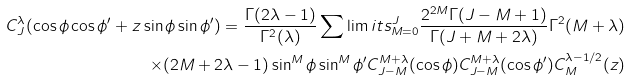<formula> <loc_0><loc_0><loc_500><loc_500>C _ { J } ^ { \lambda } ( \cos \phi \cos \phi ^ { \prime } + z \sin \phi \sin \phi ^ { \prime } ) = \frac { \Gamma ( 2 \lambda - 1 ) } { \Gamma ^ { 2 } ( \lambda ) } \sum \lim i t s _ { M = 0 } ^ { J } \frac { 2 ^ { 2 M } \Gamma ( J - M + 1 ) } { \Gamma ( J + M + 2 \lambda ) } \Gamma ^ { 2 } ( M + \lambda ) \\ \times ( 2 M + 2 \lambda - 1 ) \sin ^ { M } \phi \sin ^ { M } \phi ^ { \prime } C ^ { M + \lambda } _ { J - M } ( \cos \phi ) C ^ { M + \lambda } _ { J - M } ( \cos \phi ^ { \prime } ) C _ { M } ^ { \lambda - 1 / 2 } ( z )</formula> 